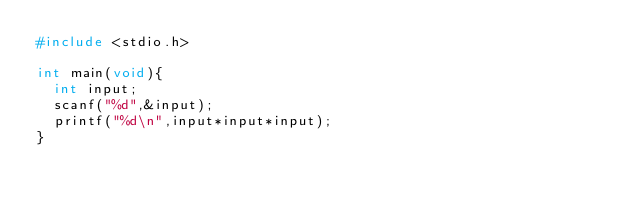<code> <loc_0><loc_0><loc_500><loc_500><_C_>#include <stdio.h>

int main(void){
  int input;
  scanf("%d",&input);
  printf("%d\n",input*input*input);
}</code> 